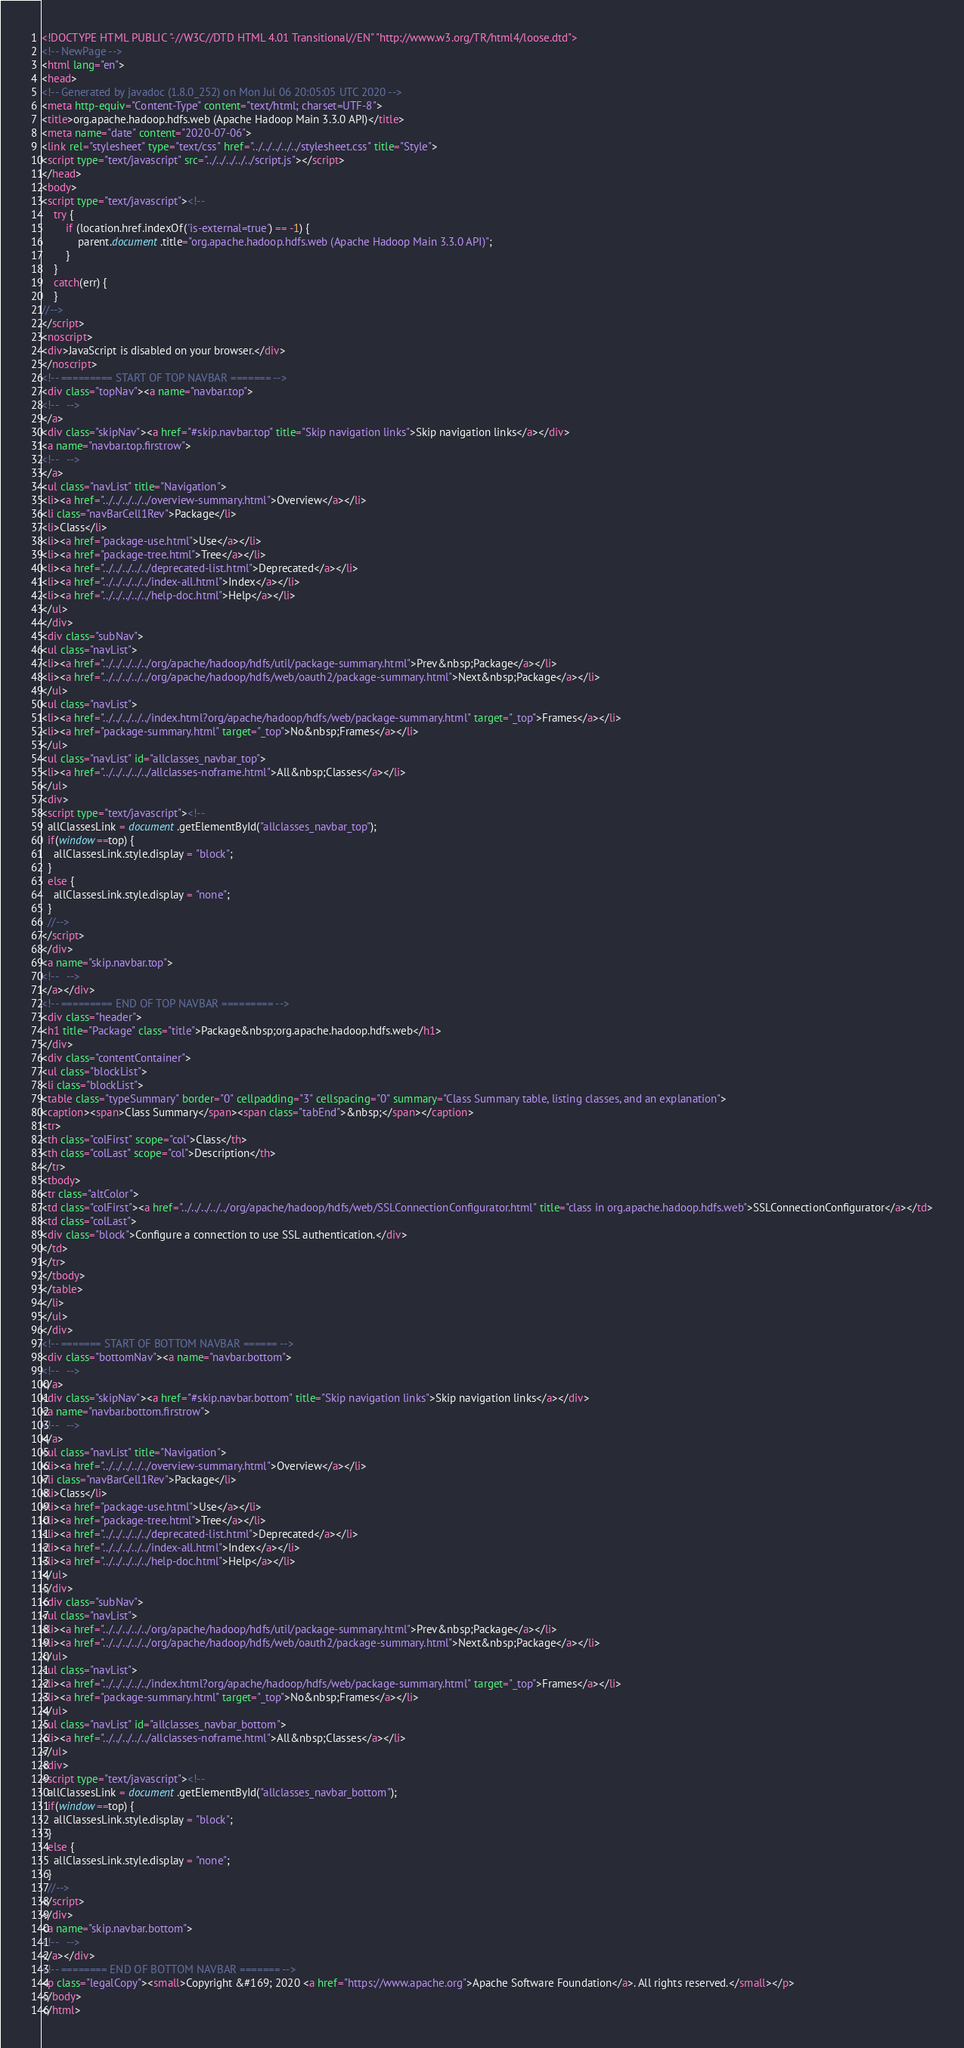<code> <loc_0><loc_0><loc_500><loc_500><_HTML_><!DOCTYPE HTML PUBLIC "-//W3C//DTD HTML 4.01 Transitional//EN" "http://www.w3.org/TR/html4/loose.dtd">
<!-- NewPage -->
<html lang="en">
<head>
<!-- Generated by javadoc (1.8.0_252) on Mon Jul 06 20:05:05 UTC 2020 -->
<meta http-equiv="Content-Type" content="text/html; charset=UTF-8">
<title>org.apache.hadoop.hdfs.web (Apache Hadoop Main 3.3.0 API)</title>
<meta name="date" content="2020-07-06">
<link rel="stylesheet" type="text/css" href="../../../../../stylesheet.css" title="Style">
<script type="text/javascript" src="../../../../../script.js"></script>
</head>
<body>
<script type="text/javascript"><!--
    try {
        if (location.href.indexOf('is-external=true') == -1) {
            parent.document.title="org.apache.hadoop.hdfs.web (Apache Hadoop Main 3.3.0 API)";
        }
    }
    catch(err) {
    }
//-->
</script>
<noscript>
<div>JavaScript is disabled on your browser.</div>
</noscript>
<!-- ========= START OF TOP NAVBAR ======= -->
<div class="topNav"><a name="navbar.top">
<!--   -->
</a>
<div class="skipNav"><a href="#skip.navbar.top" title="Skip navigation links">Skip navigation links</a></div>
<a name="navbar.top.firstrow">
<!--   -->
</a>
<ul class="navList" title="Navigation">
<li><a href="../../../../../overview-summary.html">Overview</a></li>
<li class="navBarCell1Rev">Package</li>
<li>Class</li>
<li><a href="package-use.html">Use</a></li>
<li><a href="package-tree.html">Tree</a></li>
<li><a href="../../../../../deprecated-list.html">Deprecated</a></li>
<li><a href="../../../../../index-all.html">Index</a></li>
<li><a href="../../../../../help-doc.html">Help</a></li>
</ul>
</div>
<div class="subNav">
<ul class="navList">
<li><a href="../../../../../org/apache/hadoop/hdfs/util/package-summary.html">Prev&nbsp;Package</a></li>
<li><a href="../../../../../org/apache/hadoop/hdfs/web/oauth2/package-summary.html">Next&nbsp;Package</a></li>
</ul>
<ul class="navList">
<li><a href="../../../../../index.html?org/apache/hadoop/hdfs/web/package-summary.html" target="_top">Frames</a></li>
<li><a href="package-summary.html" target="_top">No&nbsp;Frames</a></li>
</ul>
<ul class="navList" id="allclasses_navbar_top">
<li><a href="../../../../../allclasses-noframe.html">All&nbsp;Classes</a></li>
</ul>
<div>
<script type="text/javascript"><!--
  allClassesLink = document.getElementById("allclasses_navbar_top");
  if(window==top) {
    allClassesLink.style.display = "block";
  }
  else {
    allClassesLink.style.display = "none";
  }
  //-->
</script>
</div>
<a name="skip.navbar.top">
<!--   -->
</a></div>
<!-- ========= END OF TOP NAVBAR ========= -->
<div class="header">
<h1 title="Package" class="title">Package&nbsp;org.apache.hadoop.hdfs.web</h1>
</div>
<div class="contentContainer">
<ul class="blockList">
<li class="blockList">
<table class="typeSummary" border="0" cellpadding="3" cellspacing="0" summary="Class Summary table, listing classes, and an explanation">
<caption><span>Class Summary</span><span class="tabEnd">&nbsp;</span></caption>
<tr>
<th class="colFirst" scope="col">Class</th>
<th class="colLast" scope="col">Description</th>
</tr>
<tbody>
<tr class="altColor">
<td class="colFirst"><a href="../../../../../org/apache/hadoop/hdfs/web/SSLConnectionConfigurator.html" title="class in org.apache.hadoop.hdfs.web">SSLConnectionConfigurator</a></td>
<td class="colLast">
<div class="block">Configure a connection to use SSL authentication.</div>
</td>
</tr>
</tbody>
</table>
</li>
</ul>
</div>
<!-- ======= START OF BOTTOM NAVBAR ====== -->
<div class="bottomNav"><a name="navbar.bottom">
<!--   -->
</a>
<div class="skipNav"><a href="#skip.navbar.bottom" title="Skip navigation links">Skip navigation links</a></div>
<a name="navbar.bottom.firstrow">
<!--   -->
</a>
<ul class="navList" title="Navigation">
<li><a href="../../../../../overview-summary.html">Overview</a></li>
<li class="navBarCell1Rev">Package</li>
<li>Class</li>
<li><a href="package-use.html">Use</a></li>
<li><a href="package-tree.html">Tree</a></li>
<li><a href="../../../../../deprecated-list.html">Deprecated</a></li>
<li><a href="../../../../../index-all.html">Index</a></li>
<li><a href="../../../../../help-doc.html">Help</a></li>
</ul>
</div>
<div class="subNav">
<ul class="navList">
<li><a href="../../../../../org/apache/hadoop/hdfs/util/package-summary.html">Prev&nbsp;Package</a></li>
<li><a href="../../../../../org/apache/hadoop/hdfs/web/oauth2/package-summary.html">Next&nbsp;Package</a></li>
</ul>
<ul class="navList">
<li><a href="../../../../../index.html?org/apache/hadoop/hdfs/web/package-summary.html" target="_top">Frames</a></li>
<li><a href="package-summary.html" target="_top">No&nbsp;Frames</a></li>
</ul>
<ul class="navList" id="allclasses_navbar_bottom">
<li><a href="../../../../../allclasses-noframe.html">All&nbsp;Classes</a></li>
</ul>
<div>
<script type="text/javascript"><!--
  allClassesLink = document.getElementById("allclasses_navbar_bottom");
  if(window==top) {
    allClassesLink.style.display = "block";
  }
  else {
    allClassesLink.style.display = "none";
  }
  //-->
</script>
</div>
<a name="skip.navbar.bottom">
<!--   -->
</a></div>
<!-- ======== END OF BOTTOM NAVBAR ======= -->
<p class="legalCopy"><small>Copyright &#169; 2020 <a href="https://www.apache.org">Apache Software Foundation</a>. All rights reserved.</small></p>
</body>
</html>
</code> 